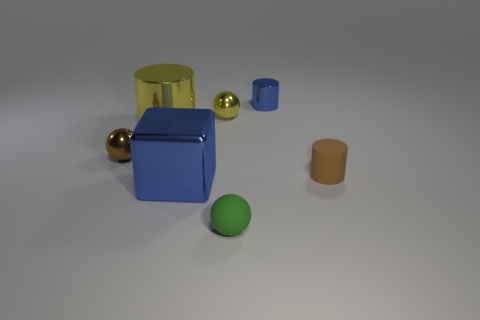There is a metal thing that is the same color as the big shiny cylinder; what shape is it?
Your answer should be very brief. Sphere. What number of brown matte things are the same size as the brown cylinder?
Ensure brevity in your answer.  0. Does the blue thing that is behind the tiny brown sphere have the same material as the brown cylinder?
Provide a succinct answer. No. Is there a small brown metal thing?
Make the answer very short. Yes. There is a blue cylinder that is the same material as the large blue object; what size is it?
Your response must be concise. Small. Are there any large things of the same color as the big cube?
Make the answer very short. No. Do the metallic thing that is in front of the tiny brown rubber cylinder and the large thing behind the brown rubber object have the same color?
Your answer should be very brief. No. There is a metal cylinder that is the same color as the large metallic block; what size is it?
Make the answer very short. Small. Are there any small cylinders that have the same material as the big cube?
Keep it short and to the point. Yes. What color is the metallic cube?
Offer a very short reply. Blue. 